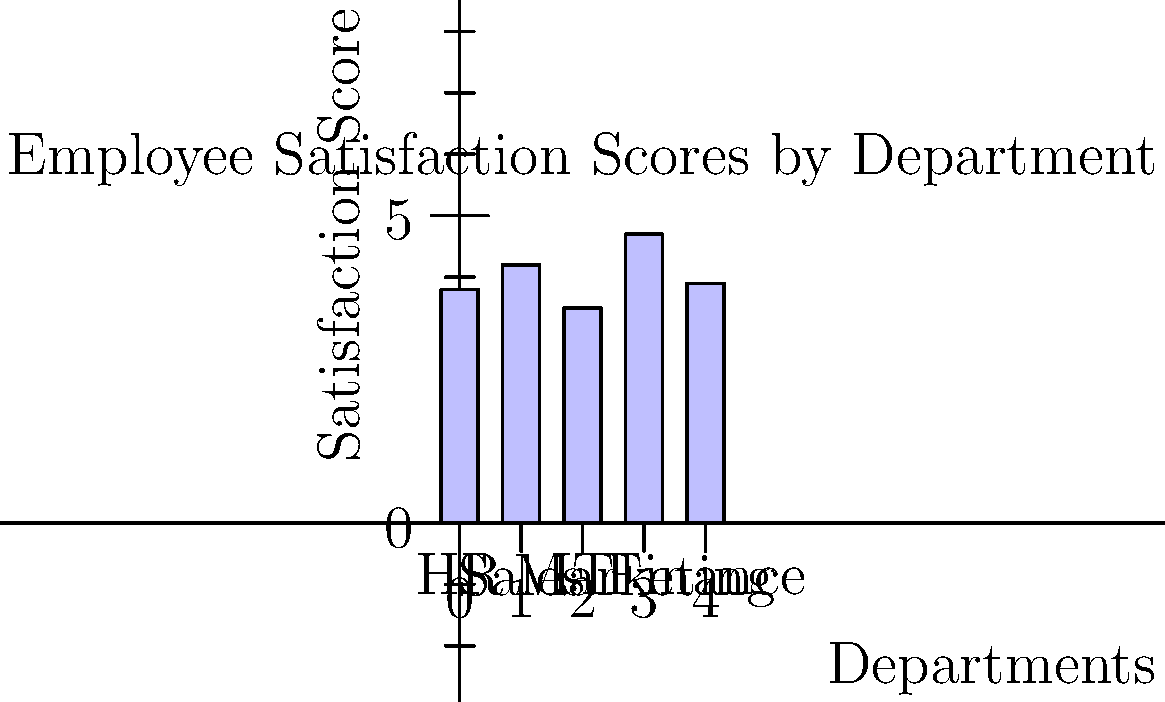As an HR manager specializing in employee relations, you've conducted a company-wide satisfaction survey. The bar chart shows the average satisfaction scores for different departments. Which department has the highest satisfaction score, and what strategies might you recommend to improve satisfaction in the lowest-scoring department? To answer this question, we need to analyze the bar chart and interpret the data:

1. Identify the highest satisfaction score:
   - HR: 3.8
   - Sales: 4.2
   - IT: 3.5
   - Marketing: 4.7
   - Finance: 3.9

   The highest score is 4.7, corresponding to the Marketing department.

2. Identify the lowest satisfaction score:
   The lowest score is 3.5, corresponding to the IT department.

3. Strategies to improve satisfaction in the IT department:
   a) Conduct focus groups or interviews with IT employees to understand specific issues.
   b) Analyze workload and stress levels in the IT department.
   c) Assess career development opportunities and training programs.
   d) Review compensation and benefits packages for IT roles.
   e) Improve communication between IT and other departments.
   f) Implement recognition programs for IT achievements.
   g) Enhance work-life balance initiatives for IT staff.

4. Formulate a concise answer that addresses both parts of the question.
Answer: Marketing has the highest satisfaction (4.7). To improve IT satisfaction: conduct interviews, analyze workload, enhance career development, review compensation, improve interdepartmental communication, implement recognition programs, and promote work-life balance. 